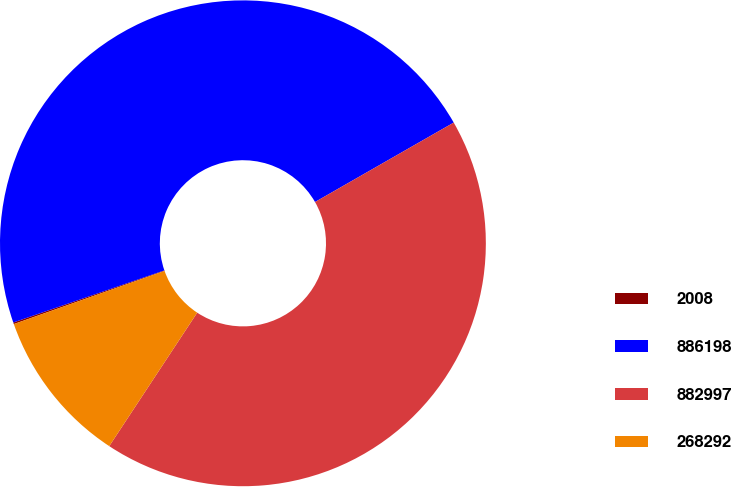<chart> <loc_0><loc_0><loc_500><loc_500><pie_chart><fcel>2008<fcel>886198<fcel>882997<fcel>268292<nl><fcel>0.11%<fcel>47.01%<fcel>42.55%<fcel>10.33%<nl></chart> 